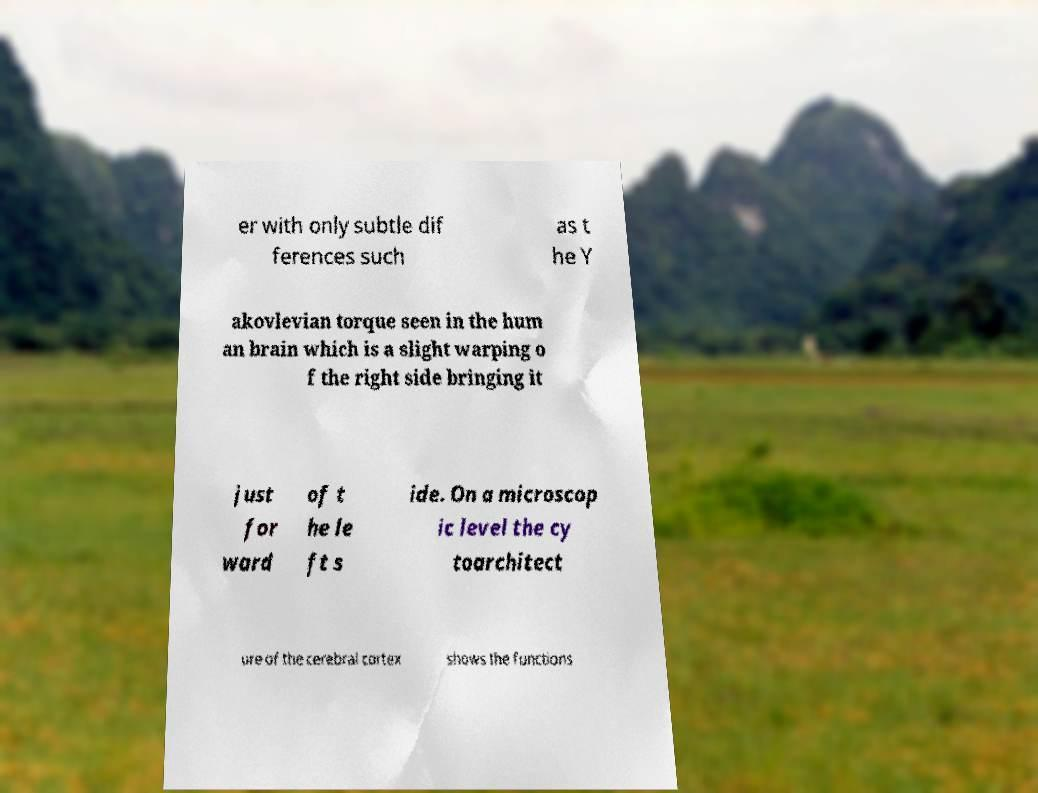Could you extract and type out the text from this image? er with only subtle dif ferences such as t he Y akovlevian torque seen in the hum an brain which is a slight warping o f the right side bringing it just for ward of t he le ft s ide. On a microscop ic level the cy toarchitect ure of the cerebral cortex shows the functions 